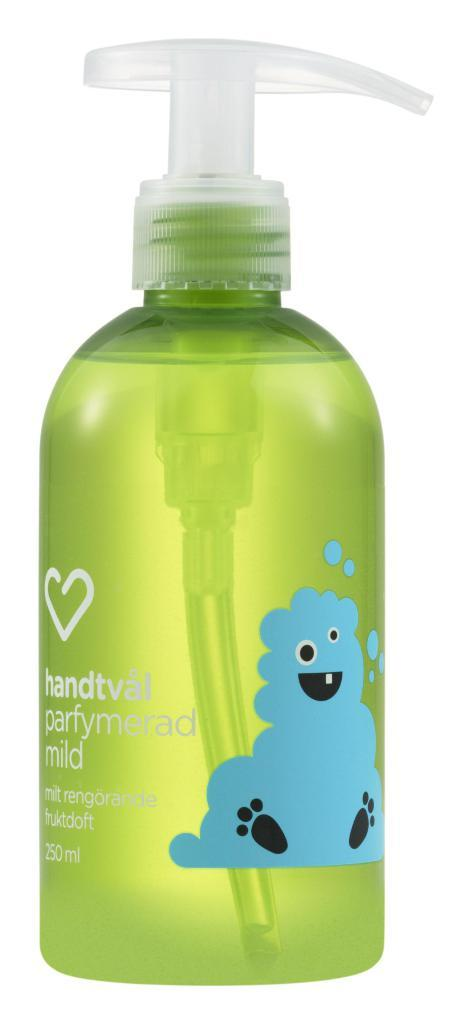What object can be seen in the image? There is a bottle in the image. What color is the bottle? The bottle is green. What part of the bottle has a different color? The handle of the bottle is white. What is featured on the bottle besides its color? There is a picture printed on the bottle. What color is the picture on the bottle? The picture is in blue. Can you tell me how many nuts are on the person in the image? There is no person present in the image, and therefore no nuts can be observed. What letters are written on the person in the image? There is no person present in the image, and therefore no letters can be observed. 